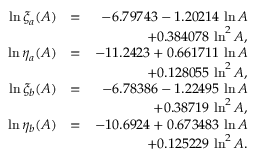<formula> <loc_0><loc_0><loc_500><loc_500>\begin{array} { r l r } { \ln \xi _ { a } ( A ) } & { = } & { - 6 . 7 9 7 4 3 - 1 . 2 0 2 1 4 \, \ln A } \\ & { + 0 . 3 8 4 0 7 8 \, \ln ^ { 2 } A , } \\ { \ln \eta _ { a } ( A ) } & { = } & { - 1 1 . 2 4 2 3 + 0 . 6 6 1 7 1 1 \, \ln A } \\ & { + 0 . 1 2 8 0 5 5 \, \ln ^ { 2 } A , } \\ { \ln \xi _ { b } ( A ) } & { = } & { - 6 . 7 8 3 8 6 - 1 . 2 2 4 9 5 \, \ln A } \\ & { + 0 . 3 8 7 1 9 \, \ln ^ { 2 } A , } \\ { \ln \eta _ { b } ( A ) } & { = } & { - 1 0 . 6 9 2 4 + 0 . 6 7 3 4 8 3 \, \ln A } \\ & { + 0 . 1 2 5 2 2 9 \, \ln ^ { 2 } A . } \end{array}</formula> 